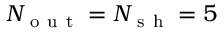<formula> <loc_0><loc_0><loc_500><loc_500>N _ { o u t } = N _ { s h } = 5</formula> 